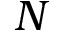<formula> <loc_0><loc_0><loc_500><loc_500>N</formula> 